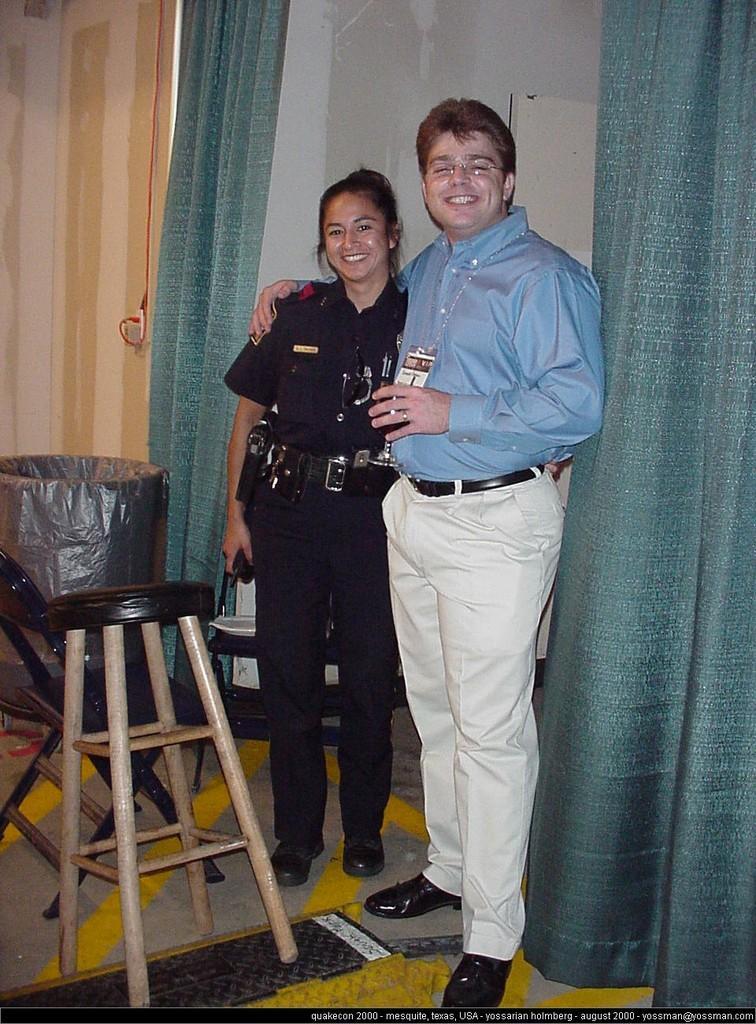Please provide a concise description of this image. On the background we can see wall, curtains. This is a trash can. Here we can see chair and a table. Near to it we can see one man and a woman standing and smiling. This is a floor. 